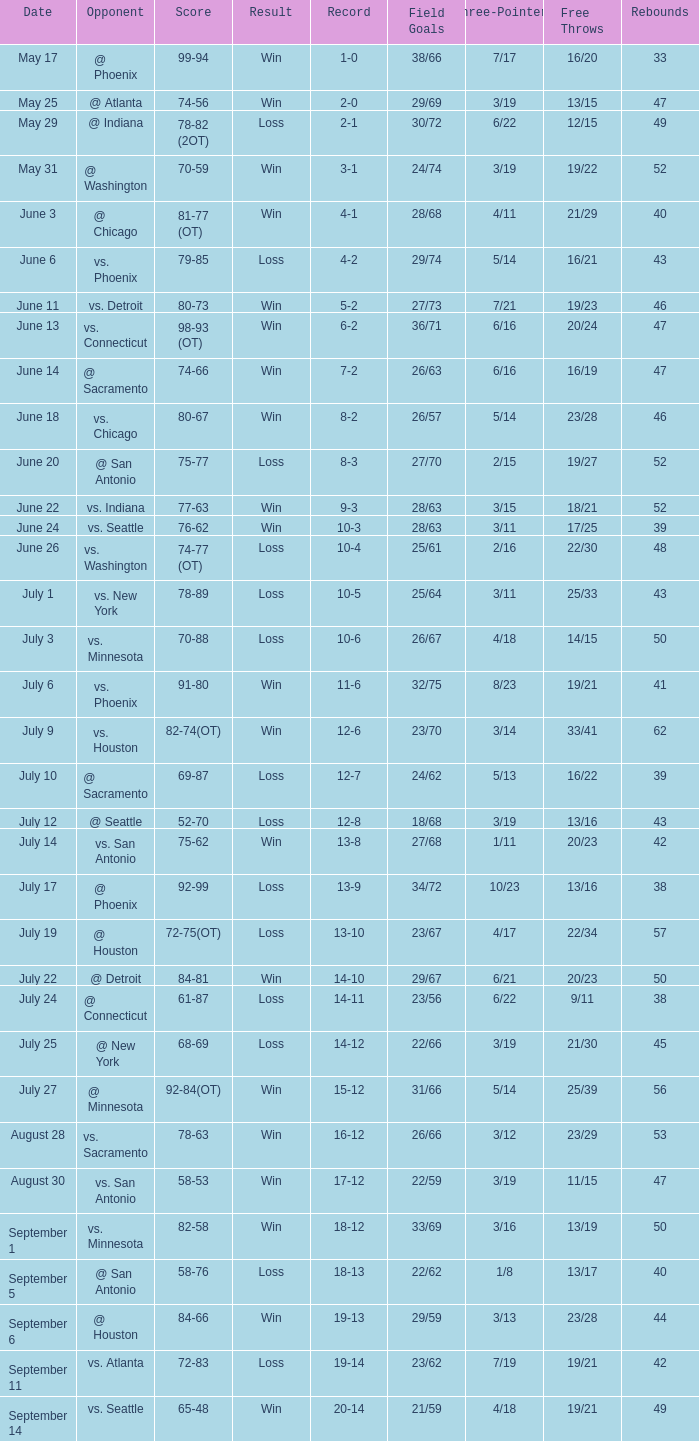What is the Record of the game with a Score of 65-48? 20-14. Can you parse all the data within this table? {'header': ['Date', 'Opponent', 'Score', 'Result', 'Record', 'Field Goals', 'Three-Pointers', 'Free Throws', 'Rebounds'], 'rows': [['May 17', '@ Phoenix', '99-94', 'Win', '1-0', '38/66', '7/17', '16/20', '33'], ['May 25', '@ Atlanta', '74-56', 'Win', '2-0', '29/69', '3/19', '13/15', '47'], ['May 29', '@ Indiana', '78-82 (2OT)', 'Loss', '2-1', '30/72', '6/22', '12/15', '49'], ['May 31', '@ Washington', '70-59', 'Win', '3-1', '24/74', '3/19', '19/22', '52'], ['June 3', '@ Chicago', '81-77 (OT)', 'Win', '4-1', '28/68', '4/11', '21/29', '40'], ['June 6', 'vs. Phoenix', '79-85', 'Loss', '4-2', '29/74', '5/14', '16/21', '43'], ['June 11', 'vs. Detroit', '80-73', 'Win', '5-2', '27/73', '7/21', '19/23', '46'], ['June 13', 'vs. Connecticut', '98-93 (OT)', 'Win', '6-2', '36/71', '6/16', '20/24', '47'], ['June 14', '@ Sacramento', '74-66', 'Win', '7-2', '26/63', '6/16', '16/19', '47'], ['June 18', 'vs. Chicago', '80-67', 'Win', '8-2', '26/57', '5/14', '23/28', '46'], ['June 20', '@ San Antonio', '75-77', 'Loss', '8-3', '27/70', '2/15', '19/27', '52'], ['June 22', 'vs. Indiana', '77-63', 'Win', '9-3', '28/63', '3/15', '18/21', '52'], ['June 24', 'vs. Seattle', '76-62', 'Win', '10-3', '28/63', '3/11', '17/25', '39'], ['June 26', 'vs. Washington', '74-77 (OT)', 'Loss', '10-4', '25/61', '2/16', '22/30', '48'], ['July 1', 'vs. New York', '78-89', 'Loss', '10-5', '25/64', '3/11', '25/33', '43'], ['July 3', 'vs. Minnesota', '70-88', 'Loss', '10-6', '26/67', '4/18', '14/15', '50'], ['July 6', 'vs. Phoenix', '91-80', 'Win', '11-6', '32/75', '8/23', '19/21', '41'], ['July 9', 'vs. Houston', '82-74(OT)', 'Win', '12-6', '23/70', '3/14', '33/41', '62'], ['July 10', '@ Sacramento', '69-87', 'Loss', '12-7', '24/62', '5/13', '16/22', '39'], ['July 12', '@ Seattle', '52-70', 'Loss', '12-8', '18/68', '3/19', '13/16', '43'], ['July 14', 'vs. San Antonio', '75-62', 'Win', '13-8', '27/68', '1/11', '20/23', '42'], ['July 17', '@ Phoenix', '92-99', 'Loss', '13-9', '34/72', '10/23', '13/16', '38'], ['July 19', '@ Houston', '72-75(OT)', 'Loss', '13-10', '23/67', '4/17', '22/34', '57'], ['July 22', '@ Detroit', '84-81', 'Win', '14-10', '29/67', '6/21', '20/23', '50'], ['July 24', '@ Connecticut', '61-87', 'Loss', '14-11', '23/56', '6/22', '9/11', '38'], ['July 25', '@ New York', '68-69', 'Loss', '14-12', '22/66', '3/19', '21/30', '45'], ['July 27', '@ Minnesota', '92-84(OT)', 'Win', '15-12', '31/66', '5/14', '25/39', '56'], ['August 28', 'vs. Sacramento', '78-63', 'Win', '16-12', '26/66', '3/12', '23/29', '53'], ['August 30', 'vs. San Antonio', '58-53', 'Win', '17-12', '22/59', '3/19', '11/15', '47'], ['September 1', 'vs. Minnesota', '82-58', 'Win', '18-12', '33/69', '3/16', '13/19', '50'], ['September 5', '@ San Antonio', '58-76', 'Loss', '18-13', '22/62', '1/8', '13/17', '40'], ['September 6', '@ Houston', '84-66', 'Win', '19-13', '29/59', '3/13', '23/28', '44'], ['September 11', 'vs. Atlanta', '72-83', 'Loss', '19-14', '23/62', '7/19', '19/21', '42'], ['September 14', 'vs. Seattle', '65-48', 'Win', '20-14', '21/59', '4/18', '19/21', '49']]} 